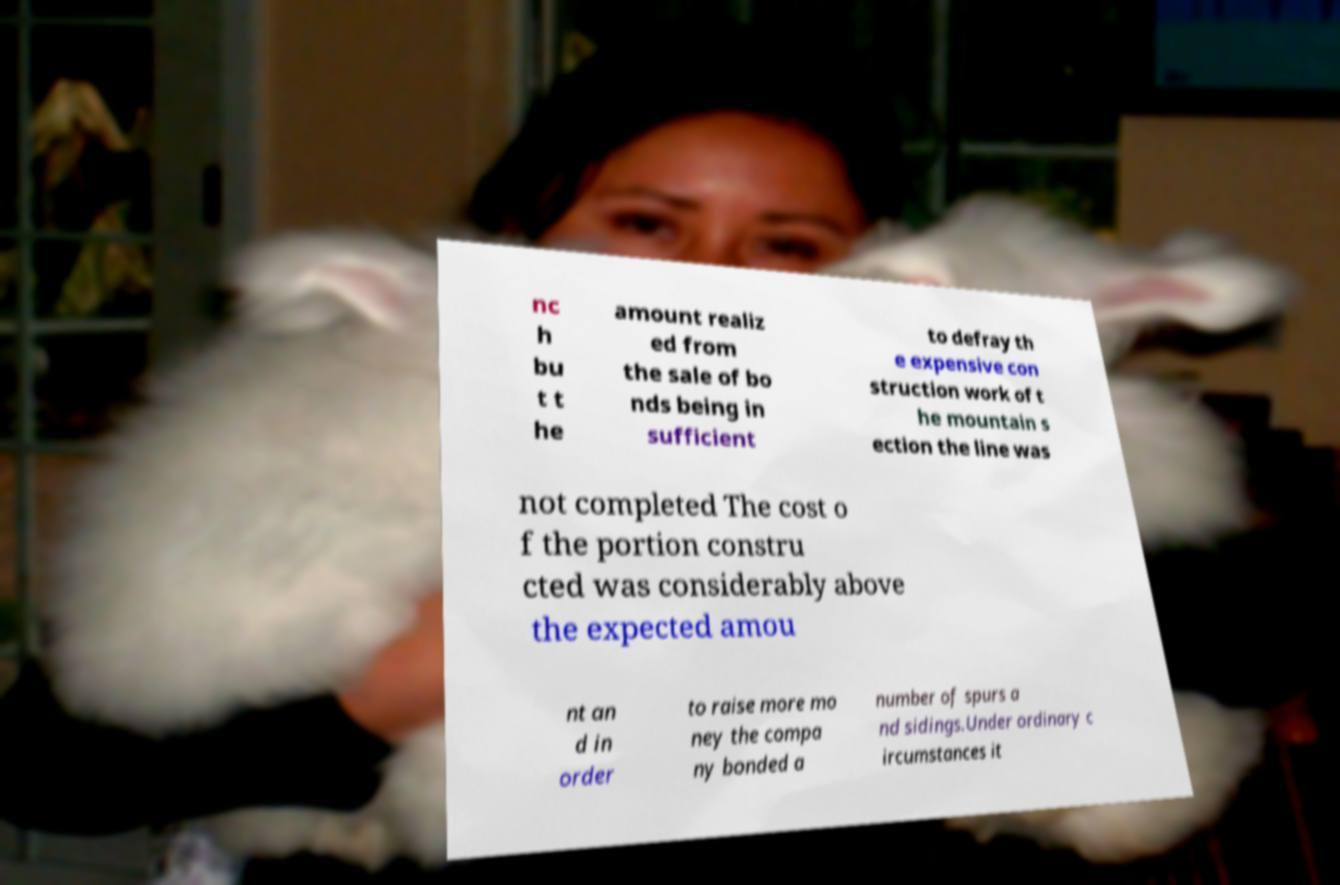Can you read and provide the text displayed in the image?This photo seems to have some interesting text. Can you extract and type it out for me? nc h bu t t he amount realiz ed from the sale of bo nds being in sufficient to defray th e expensive con struction work of t he mountain s ection the line was not completed The cost o f the portion constru cted was considerably above the expected amou nt an d in order to raise more mo ney the compa ny bonded a number of spurs a nd sidings.Under ordinary c ircumstances it 